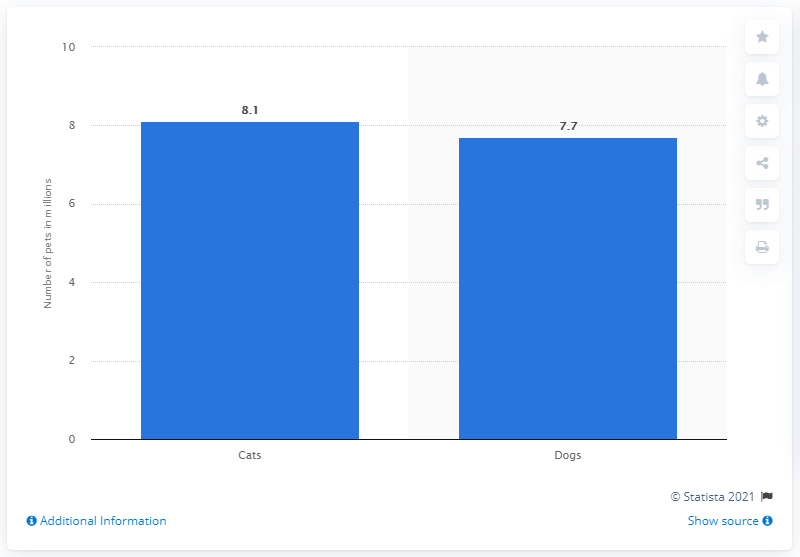Identify some key points in this picture. In 2020, there were approximately 7.7 million dogs living in Canada. There were 0.4 fewer Canadian cat owners than dog owners. In the category of pets with the largest bars, cats reign supreme. In 2020, there were 8.1 cats per household in Canada. 